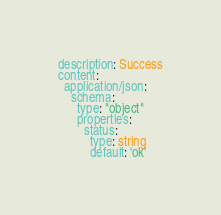Convert code to text. <code><loc_0><loc_0><loc_500><loc_500><_YAML_>description: Success
content:
  application/json:
    schema:
      type: "object"
      properties:
        status:
          type: string
          default: 'ok'</code> 